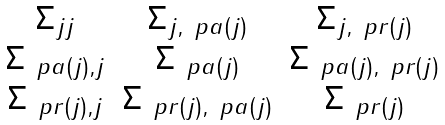<formula> <loc_0><loc_0><loc_500><loc_500>\begin{matrix} \Sigma _ { j j } & \Sigma _ { j , \ p a ( j ) } & \Sigma _ { j , \ p r ( j ) } \\ \Sigma _ { \ p a ( j ) , j } & \Sigma _ { \ p a ( j ) } & \Sigma _ { \ p a ( j ) , \ p r ( j ) } \\ \Sigma _ { \ p r ( j ) , j } & \Sigma _ { \ p r ( j ) , \ p a ( j ) } & \Sigma _ { \ p r ( j ) } \end{matrix}</formula> 